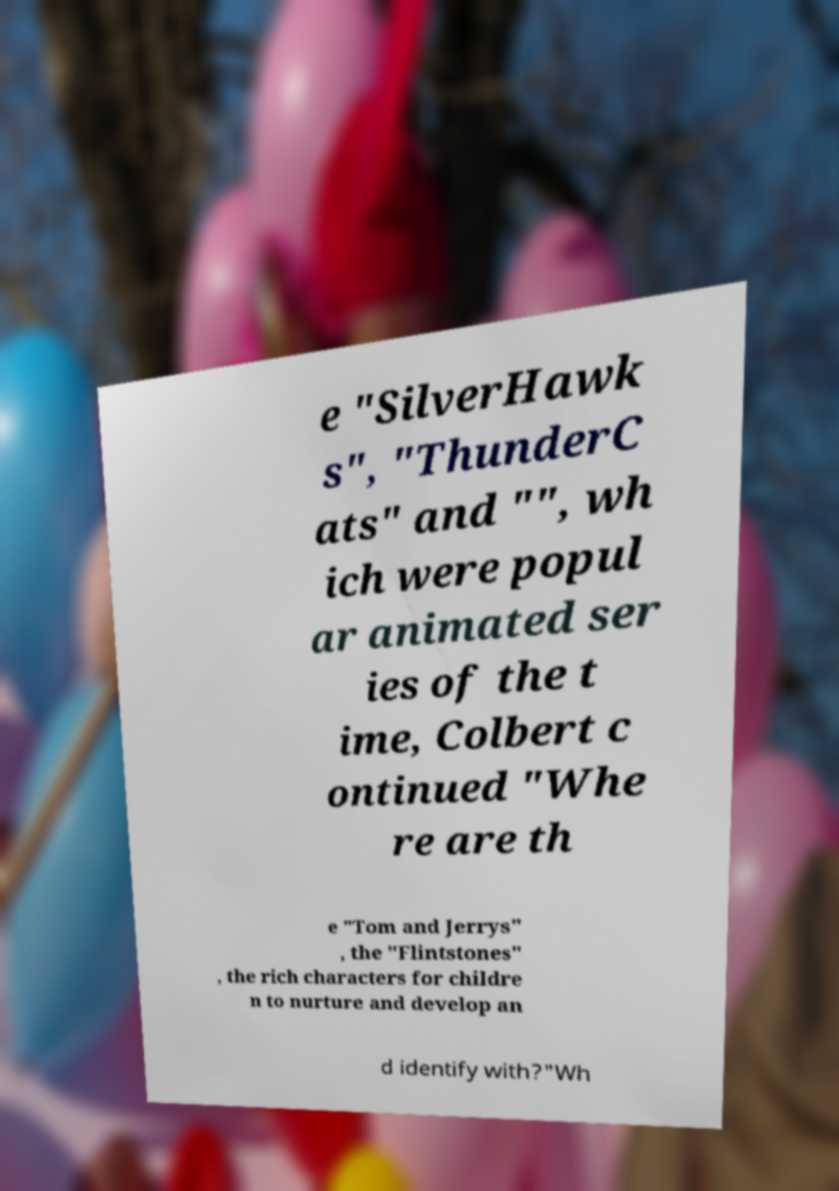There's text embedded in this image that I need extracted. Can you transcribe it verbatim? e "SilverHawk s", "ThunderC ats" and "", wh ich were popul ar animated ser ies of the t ime, Colbert c ontinued "Whe re are th e "Tom and Jerrys" , the "Flintstones" , the rich characters for childre n to nurture and develop an d identify with?"Wh 